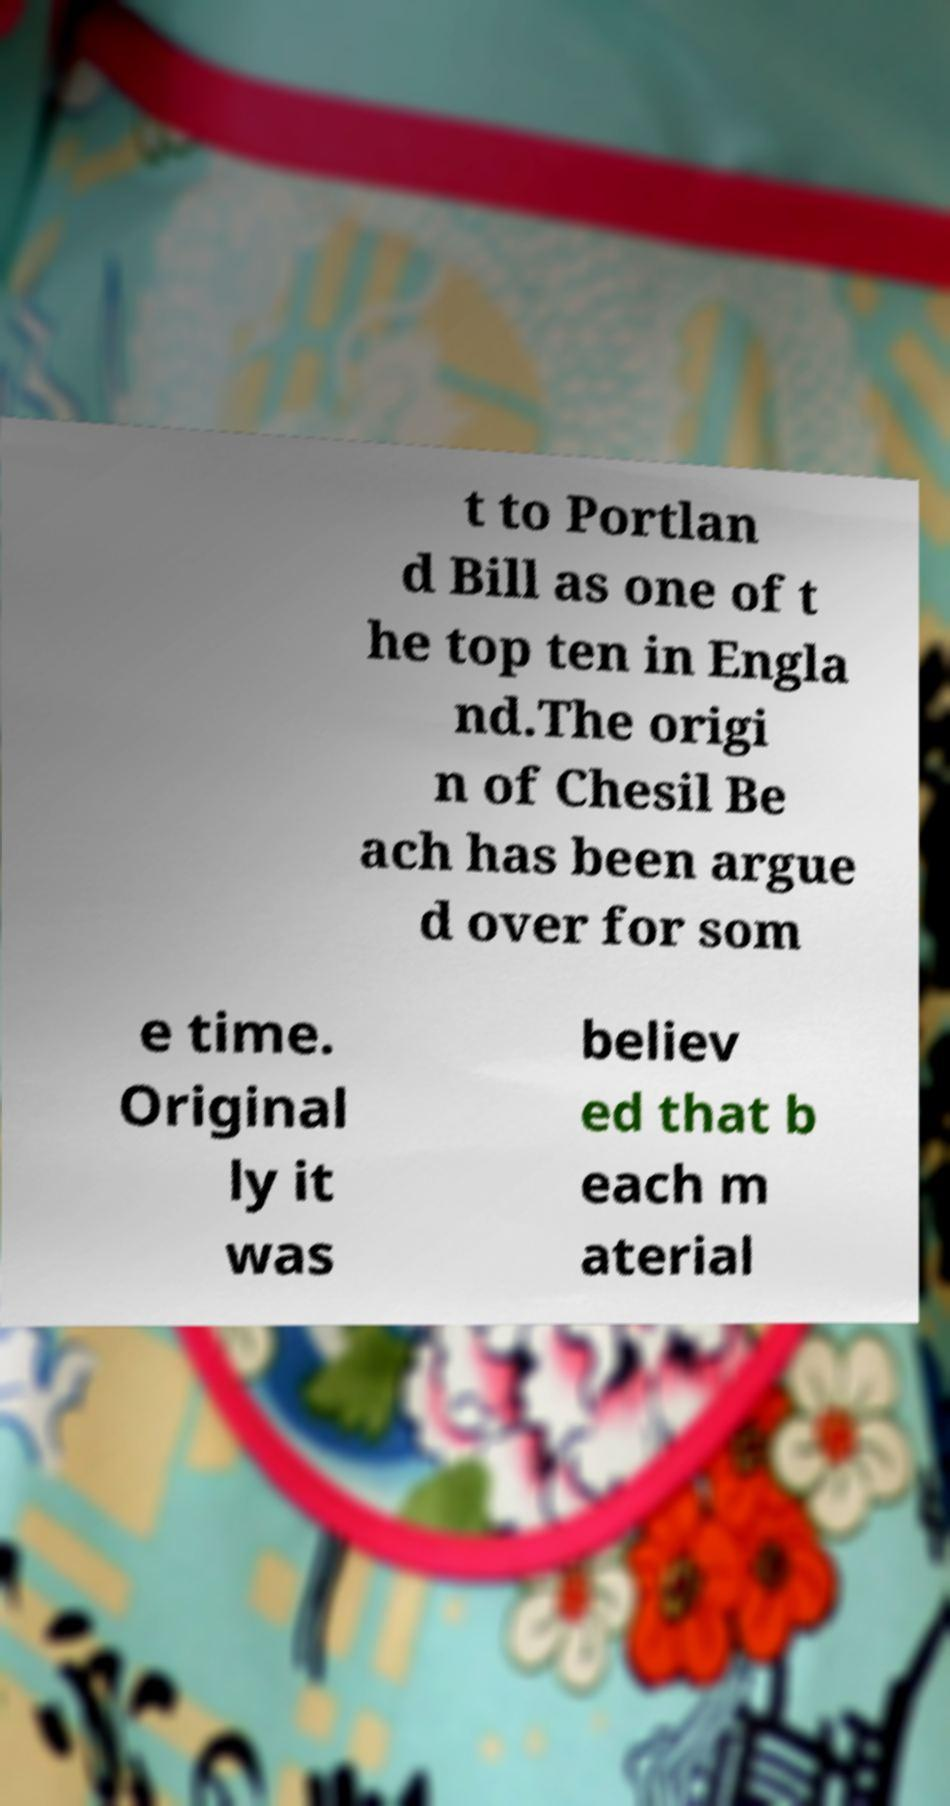Please read and relay the text visible in this image. What does it say? t to Portlan d Bill as one of t he top ten in Engla nd.The origi n of Chesil Be ach has been argue d over for som e time. Original ly it was believ ed that b each m aterial 